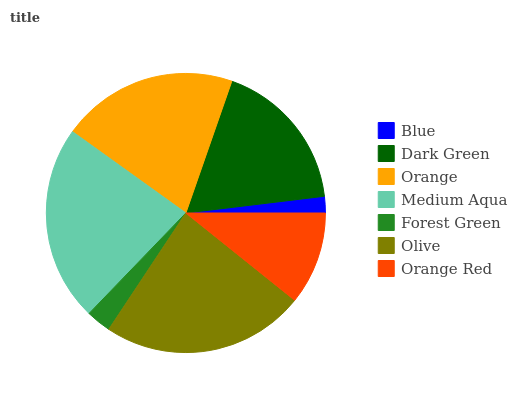Is Blue the minimum?
Answer yes or no. Yes. Is Olive the maximum?
Answer yes or no. Yes. Is Dark Green the minimum?
Answer yes or no. No. Is Dark Green the maximum?
Answer yes or no. No. Is Dark Green greater than Blue?
Answer yes or no. Yes. Is Blue less than Dark Green?
Answer yes or no. Yes. Is Blue greater than Dark Green?
Answer yes or no. No. Is Dark Green less than Blue?
Answer yes or no. No. Is Dark Green the high median?
Answer yes or no. Yes. Is Dark Green the low median?
Answer yes or no. Yes. Is Blue the high median?
Answer yes or no. No. Is Orange the low median?
Answer yes or no. No. 